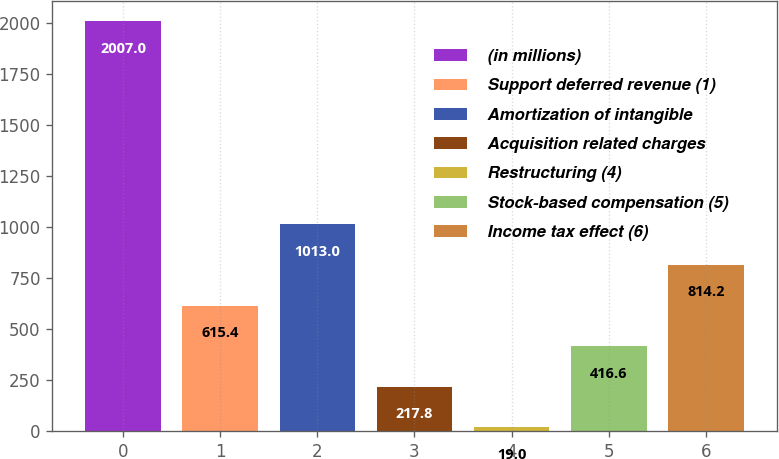<chart> <loc_0><loc_0><loc_500><loc_500><bar_chart><fcel>(in millions)<fcel>Support deferred revenue (1)<fcel>Amortization of intangible<fcel>Acquisition related charges<fcel>Restructuring (4)<fcel>Stock-based compensation (5)<fcel>Income tax effect (6)<nl><fcel>2007<fcel>615.4<fcel>1013<fcel>217.8<fcel>19<fcel>416.6<fcel>814.2<nl></chart> 